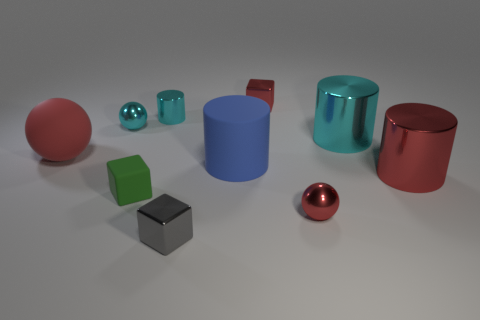There is a rubber thing that is left of the small cyan ball; is its color the same as the small shiny cube in front of the red block? No, the color is not the same. The rubber object to the left of the small cyan ball is red, while the small shiny cube in front of the red block is silver. 